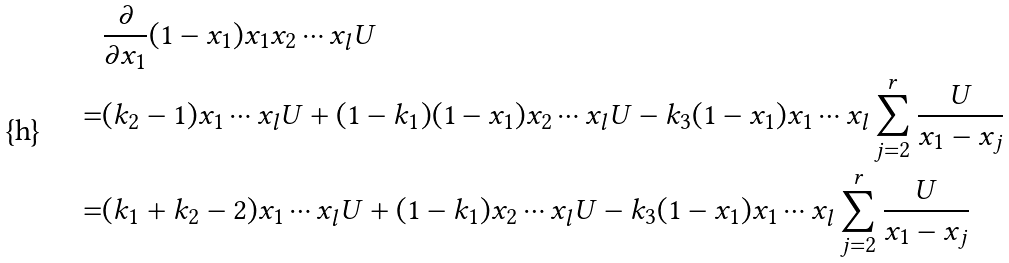<formula> <loc_0><loc_0><loc_500><loc_500>& \frac { \partial } { \partial x _ { 1 } } ( 1 - x _ { 1 } ) x _ { 1 } x _ { 2 } \cdots x _ { l } U \\ = & ( k _ { 2 } - 1 ) x _ { 1 } \cdots x _ { l } U + ( 1 - k _ { 1 } ) ( 1 - x _ { 1 } ) x _ { 2 } \cdots x _ { l } U - k _ { 3 } ( 1 - x _ { 1 } ) x _ { 1 } \cdots x _ { l } \sum _ { j = 2 } ^ { r } \frac { U } { x _ { 1 } - x _ { j } } \\ = & ( k _ { 1 } + k _ { 2 } - 2 ) x _ { 1 } \cdots x _ { l } U + ( 1 - k _ { 1 } ) x _ { 2 } \cdots x _ { l } U - k _ { 3 } ( 1 - x _ { 1 } ) x _ { 1 } \cdots x _ { l } \sum _ { j = 2 } ^ { r } \frac { U } { x _ { 1 } - x _ { j } }</formula> 